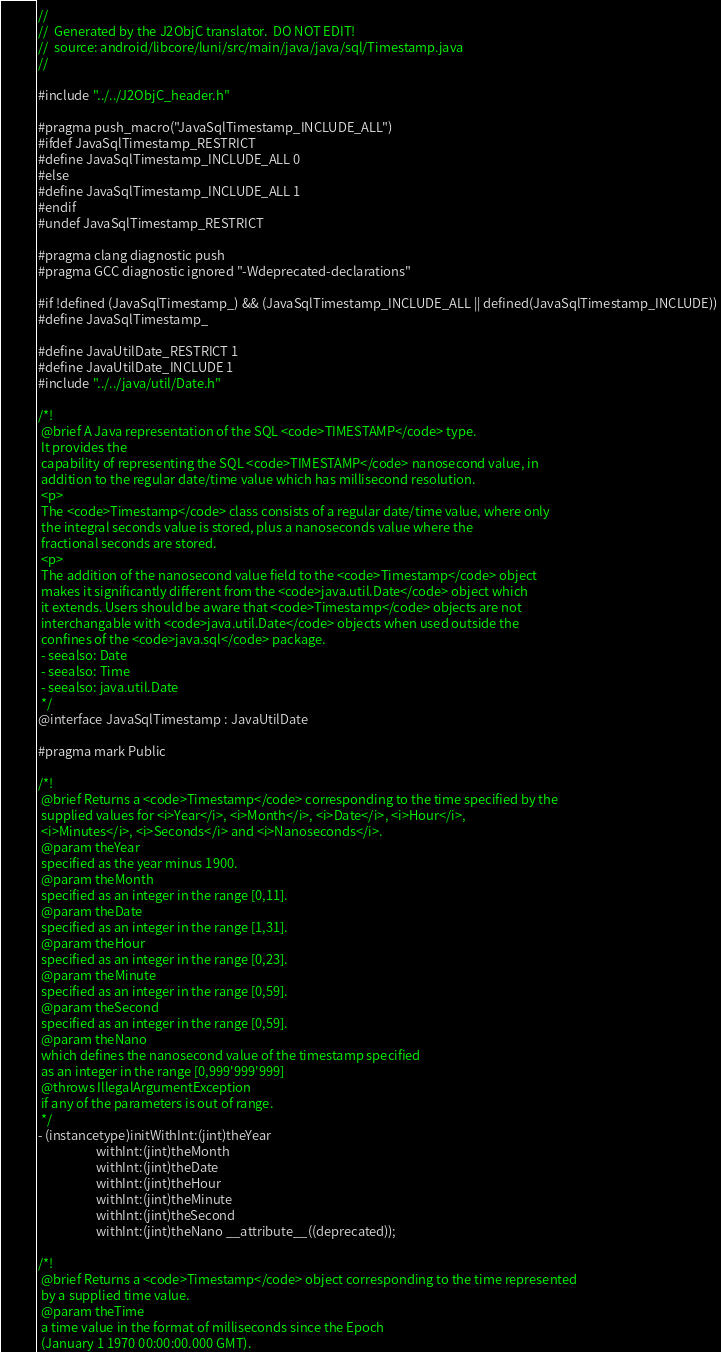Convert code to text. <code><loc_0><loc_0><loc_500><loc_500><_C_>//
//  Generated by the J2ObjC translator.  DO NOT EDIT!
//  source: android/libcore/luni/src/main/java/java/sql/Timestamp.java
//

#include "../../J2ObjC_header.h"

#pragma push_macro("JavaSqlTimestamp_INCLUDE_ALL")
#ifdef JavaSqlTimestamp_RESTRICT
#define JavaSqlTimestamp_INCLUDE_ALL 0
#else
#define JavaSqlTimestamp_INCLUDE_ALL 1
#endif
#undef JavaSqlTimestamp_RESTRICT

#pragma clang diagnostic push
#pragma GCC diagnostic ignored "-Wdeprecated-declarations"

#if !defined (JavaSqlTimestamp_) && (JavaSqlTimestamp_INCLUDE_ALL || defined(JavaSqlTimestamp_INCLUDE))
#define JavaSqlTimestamp_

#define JavaUtilDate_RESTRICT 1
#define JavaUtilDate_INCLUDE 1
#include "../../java/util/Date.h"

/*!
 @brief A Java representation of the SQL <code>TIMESTAMP</code> type.
 It provides the
 capability of representing the SQL <code>TIMESTAMP</code> nanosecond value, in
 addition to the regular date/time value which has millisecond resolution.
 <p>
 The <code>Timestamp</code> class consists of a regular date/time value, where only
 the integral seconds value is stored, plus a nanoseconds value where the
 fractional seconds are stored.
 <p>
 The addition of the nanosecond value field to the <code>Timestamp</code> object
 makes it significantly different from the <code>java.util.Date</code> object which
 it extends. Users should be aware that <code>Timestamp</code> objects are not
 interchangable with <code>java.util.Date</code> objects when used outside the
 confines of the <code>java.sql</code> package.
 - seealso: Date
 - seealso: Time
 - seealso: java.util.Date
 */
@interface JavaSqlTimestamp : JavaUtilDate

#pragma mark Public

/*!
 @brief Returns a <code>Timestamp</code> corresponding to the time specified by the
 supplied values for <i>Year</i>, <i>Month</i>, <i>Date</i>, <i>Hour</i>,
 <i>Minutes</i>, <i>Seconds</i> and <i>Nanoseconds</i>.
 @param theYear
 specified as the year minus 1900.
 @param theMonth
 specified as an integer in the range [0,11].
 @param theDate
 specified as an integer in the range [1,31].
 @param theHour
 specified as an integer in the range [0,23].
 @param theMinute
 specified as an integer in the range [0,59].
 @param theSecond
 specified as an integer in the range [0,59].
 @param theNano
 which defines the nanosecond value of the timestamp specified
 as an integer in the range [0,999'999'999]
 @throws IllegalArgumentException
 if any of the parameters is out of range.
 */
- (instancetype)initWithInt:(jint)theYear
                    withInt:(jint)theMonth
                    withInt:(jint)theDate
                    withInt:(jint)theHour
                    withInt:(jint)theMinute
                    withInt:(jint)theSecond
                    withInt:(jint)theNano __attribute__((deprecated));

/*!
 @brief Returns a <code>Timestamp</code> object corresponding to the time represented
 by a supplied time value.
 @param theTime
 a time value in the format of milliseconds since the Epoch
 (January 1 1970 00:00:00.000 GMT).</code> 